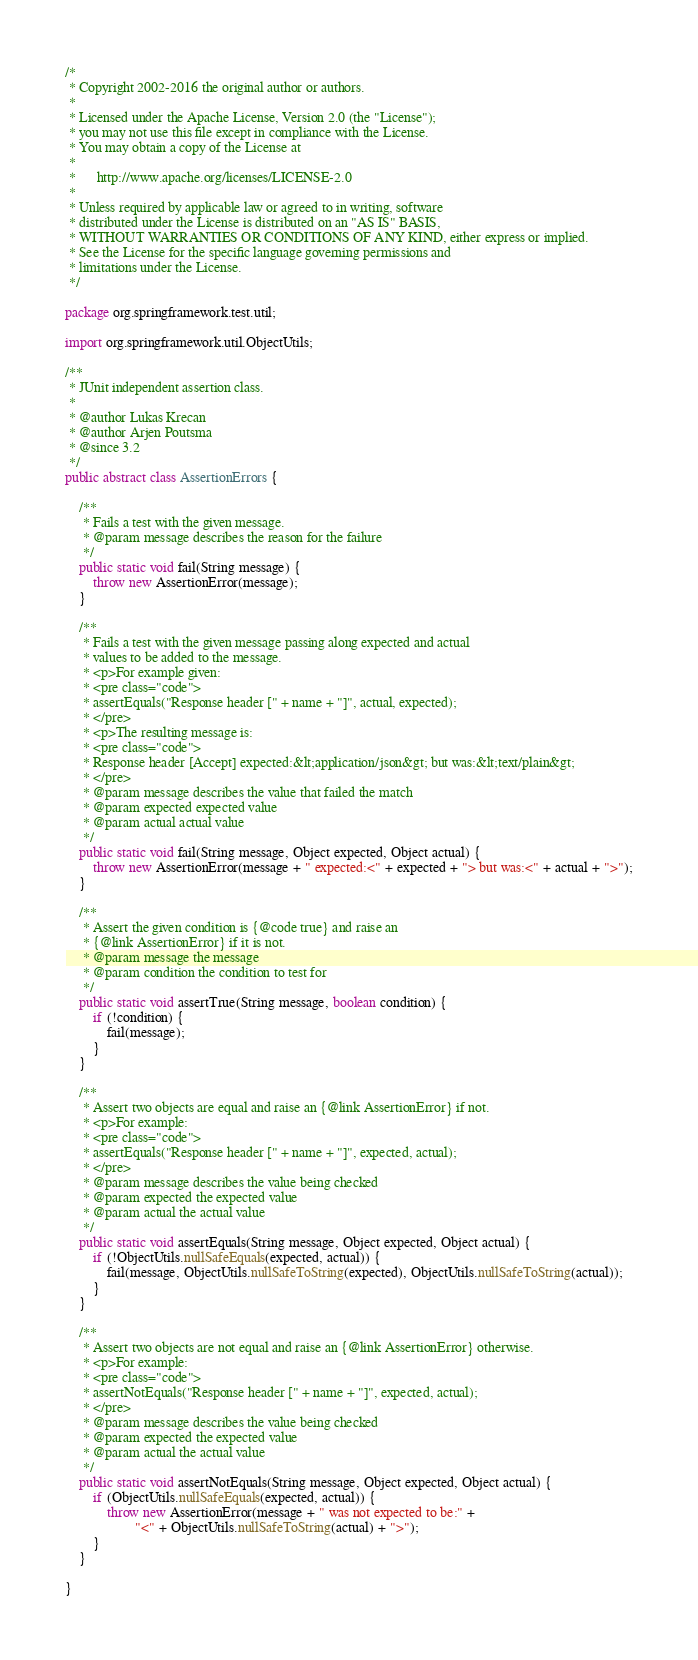Convert code to text. <code><loc_0><loc_0><loc_500><loc_500><_Java_>/*
 * Copyright 2002-2016 the original author or authors.
 *
 * Licensed under the Apache License, Version 2.0 (the "License");
 * you may not use this file except in compliance with the License.
 * You may obtain a copy of the License at
 *
 *      http://www.apache.org/licenses/LICENSE-2.0
 *
 * Unless required by applicable law or agreed to in writing, software
 * distributed under the License is distributed on an "AS IS" BASIS,
 * WITHOUT WARRANTIES OR CONDITIONS OF ANY KIND, either express or implied.
 * See the License for the specific language governing permissions and
 * limitations under the License.
 */

package org.springframework.test.util;

import org.springframework.util.ObjectUtils;

/**
 * JUnit independent assertion class.
 *
 * @author Lukas Krecan
 * @author Arjen Poutsma
 * @since 3.2
 */
public abstract class AssertionErrors {

	/**
	 * Fails a test with the given message.
	 * @param message describes the reason for the failure
	 */
	public static void fail(String message) {
		throw new AssertionError(message);
	}

	/**
	 * Fails a test with the given message passing along expected and actual
	 * values to be added to the message.
	 * <p>For example given:
	 * <pre class="code">
	 * assertEquals("Response header [" + name + "]", actual, expected);
	 * </pre>
	 * <p>The resulting message is:
	 * <pre class="code">
	 * Response header [Accept] expected:&lt;application/json&gt; but was:&lt;text/plain&gt;
	 * </pre>
	 * @param message describes the value that failed the match
	 * @param expected expected value
	 * @param actual actual value
	 */
	public static void fail(String message, Object expected, Object actual) {
		throw new AssertionError(message + " expected:<" + expected + "> but was:<" + actual + ">");
	}

	/**
	 * Assert the given condition is {@code true} and raise an
	 * {@link AssertionError} if it is not.
	 * @param message the message
	 * @param condition the condition to test for
	 */
	public static void assertTrue(String message, boolean condition) {
		if (!condition) {
			fail(message);
		}
	}

	/**
	 * Assert two objects are equal and raise an {@link AssertionError} if not.
	 * <p>For example:
	 * <pre class="code">
	 * assertEquals("Response header [" + name + "]", expected, actual);
	 * </pre>
	 * @param message describes the value being checked
	 * @param expected the expected value
	 * @param actual the actual value
	 */
	public static void assertEquals(String message, Object expected, Object actual) {
		if (!ObjectUtils.nullSafeEquals(expected, actual)) {
			fail(message, ObjectUtils.nullSafeToString(expected), ObjectUtils.nullSafeToString(actual));
		}
	}

	/**
	 * Assert two objects are not equal and raise an {@link AssertionError} otherwise.
	 * <p>For example:
	 * <pre class="code">
	 * assertNotEquals("Response header [" + name + "]", expected, actual);
	 * </pre>
	 * @param message describes the value being checked
	 * @param expected the expected value
	 * @param actual the actual value
	 */
	public static void assertNotEquals(String message, Object expected, Object actual) {
		if (ObjectUtils.nullSafeEquals(expected, actual)) {
			throw new AssertionError(message + " was not expected to be:" +
					"<" + ObjectUtils.nullSafeToString(actual) + ">");
		}
	}

}
</code> 